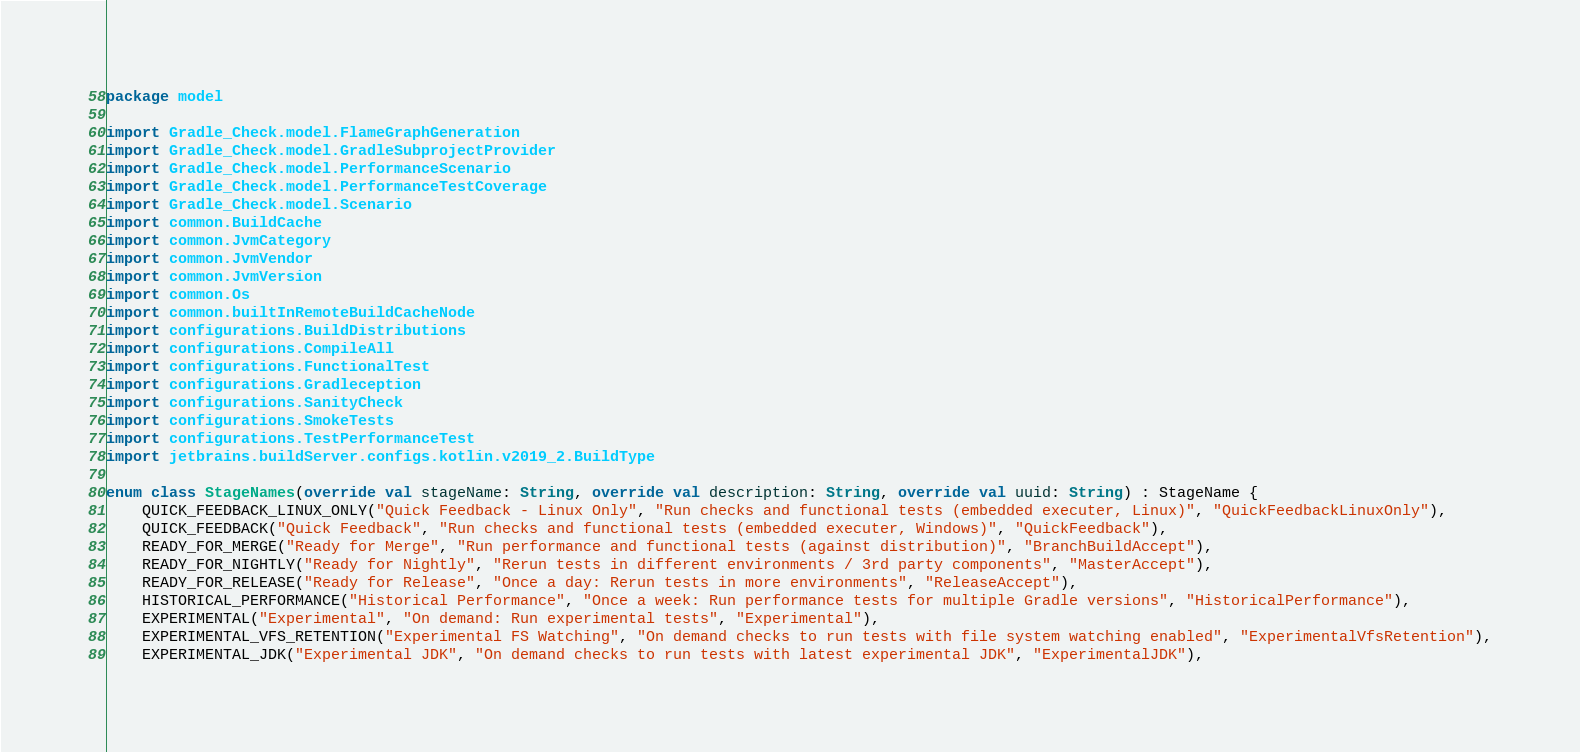Convert code to text. <code><loc_0><loc_0><loc_500><loc_500><_Kotlin_>package model

import Gradle_Check.model.FlameGraphGeneration
import Gradle_Check.model.GradleSubprojectProvider
import Gradle_Check.model.PerformanceScenario
import Gradle_Check.model.PerformanceTestCoverage
import Gradle_Check.model.Scenario
import common.BuildCache
import common.JvmCategory
import common.JvmVendor
import common.JvmVersion
import common.Os
import common.builtInRemoteBuildCacheNode
import configurations.BuildDistributions
import configurations.CompileAll
import configurations.FunctionalTest
import configurations.Gradleception
import configurations.SanityCheck
import configurations.SmokeTests
import configurations.TestPerformanceTest
import jetbrains.buildServer.configs.kotlin.v2019_2.BuildType

enum class StageNames(override val stageName: String, override val description: String, override val uuid: String) : StageName {
    QUICK_FEEDBACK_LINUX_ONLY("Quick Feedback - Linux Only", "Run checks and functional tests (embedded executer, Linux)", "QuickFeedbackLinuxOnly"),
    QUICK_FEEDBACK("Quick Feedback", "Run checks and functional tests (embedded executer, Windows)", "QuickFeedback"),
    READY_FOR_MERGE("Ready for Merge", "Run performance and functional tests (against distribution)", "BranchBuildAccept"),
    READY_FOR_NIGHTLY("Ready for Nightly", "Rerun tests in different environments / 3rd party components", "MasterAccept"),
    READY_FOR_RELEASE("Ready for Release", "Once a day: Rerun tests in more environments", "ReleaseAccept"),
    HISTORICAL_PERFORMANCE("Historical Performance", "Once a week: Run performance tests for multiple Gradle versions", "HistoricalPerformance"),
    EXPERIMENTAL("Experimental", "On demand: Run experimental tests", "Experimental"),
    EXPERIMENTAL_VFS_RETENTION("Experimental FS Watching", "On demand checks to run tests with file system watching enabled", "ExperimentalVfsRetention"),
    EXPERIMENTAL_JDK("Experimental JDK", "On demand checks to run tests with latest experimental JDK", "ExperimentalJDK"),</code> 